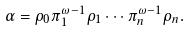Convert formula to latex. <formula><loc_0><loc_0><loc_500><loc_500>\alpha = \rho _ { 0 } \pi _ { 1 } ^ { \omega - 1 } \rho _ { 1 } \cdots \pi _ { n } ^ { \omega - 1 } \rho _ { n } .</formula> 